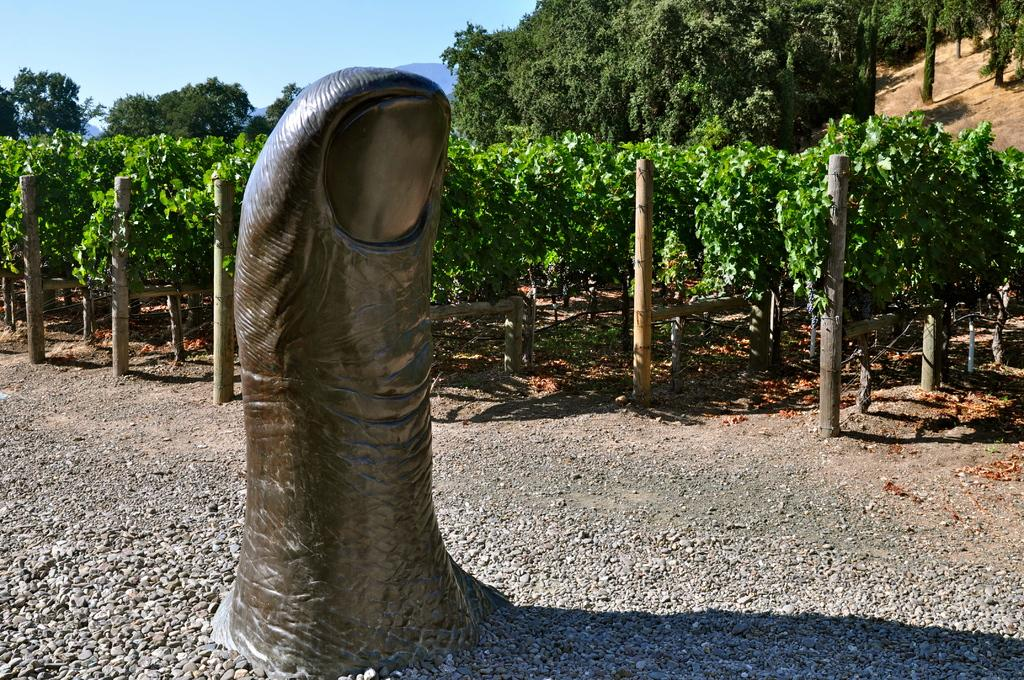What type of view is shown in the image? The image is an outside view. What can be found beside the garden in the image? There is a sculpture beside the garden in the image. Where is the tree located in the image? The tree is in the top right of the image. What is visible in the top left of the image? There is a sky in the top left of the image. What type of coat is hanging on the tree in the image? There is no coat present in the image; it features a tree and a sculpture beside a garden. Can you see any ears in the image? There are no ears visible in the image, as it features a sculpture, a tree, and a garden. 